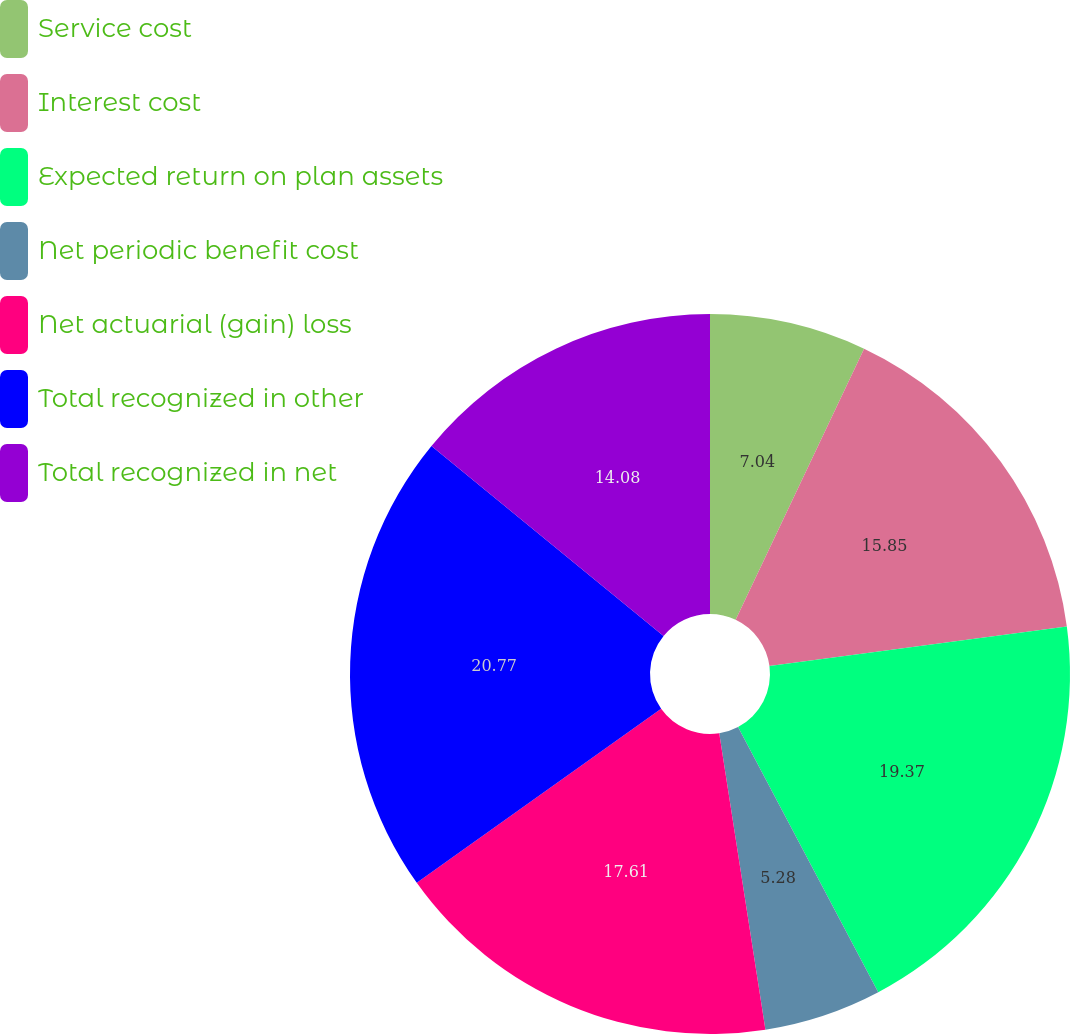Convert chart. <chart><loc_0><loc_0><loc_500><loc_500><pie_chart><fcel>Service cost<fcel>Interest cost<fcel>Expected return on plan assets<fcel>Net periodic benefit cost<fcel>Net actuarial (gain) loss<fcel>Total recognized in other<fcel>Total recognized in net<nl><fcel>7.04%<fcel>15.85%<fcel>19.37%<fcel>5.28%<fcel>17.61%<fcel>20.77%<fcel>14.08%<nl></chart> 